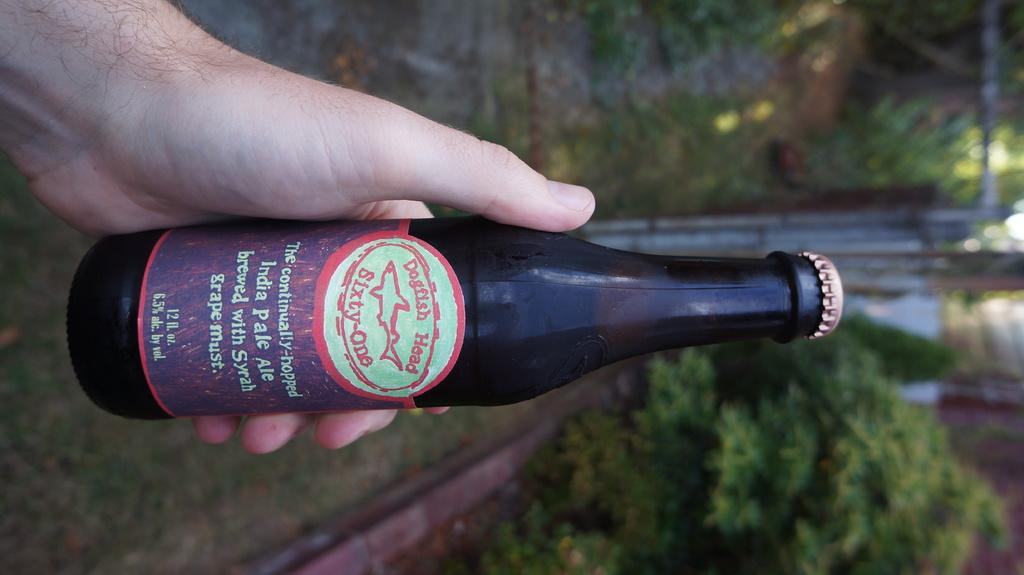Provide a one-sentence caption for the provided image. Someone holds a bottle of Dogfish Head Sixty-One India Pale Ale in an outdoor setting. 